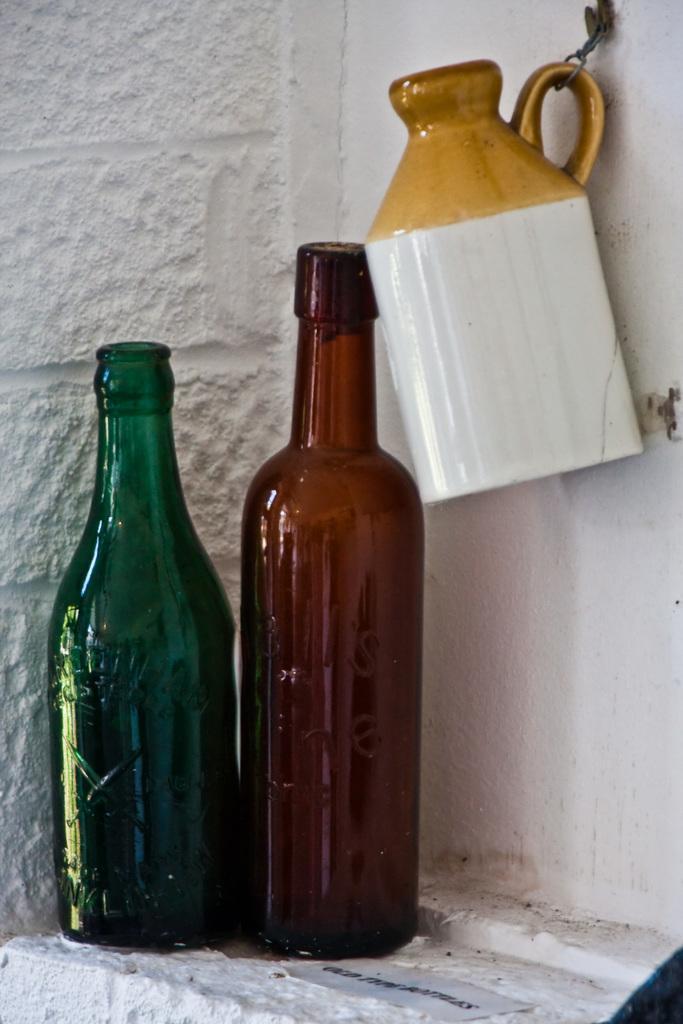Can you describe this image briefly? In this image there are two bottles and a jar. The jar is hanged to the wall. In the background, there is a wall in white color. 